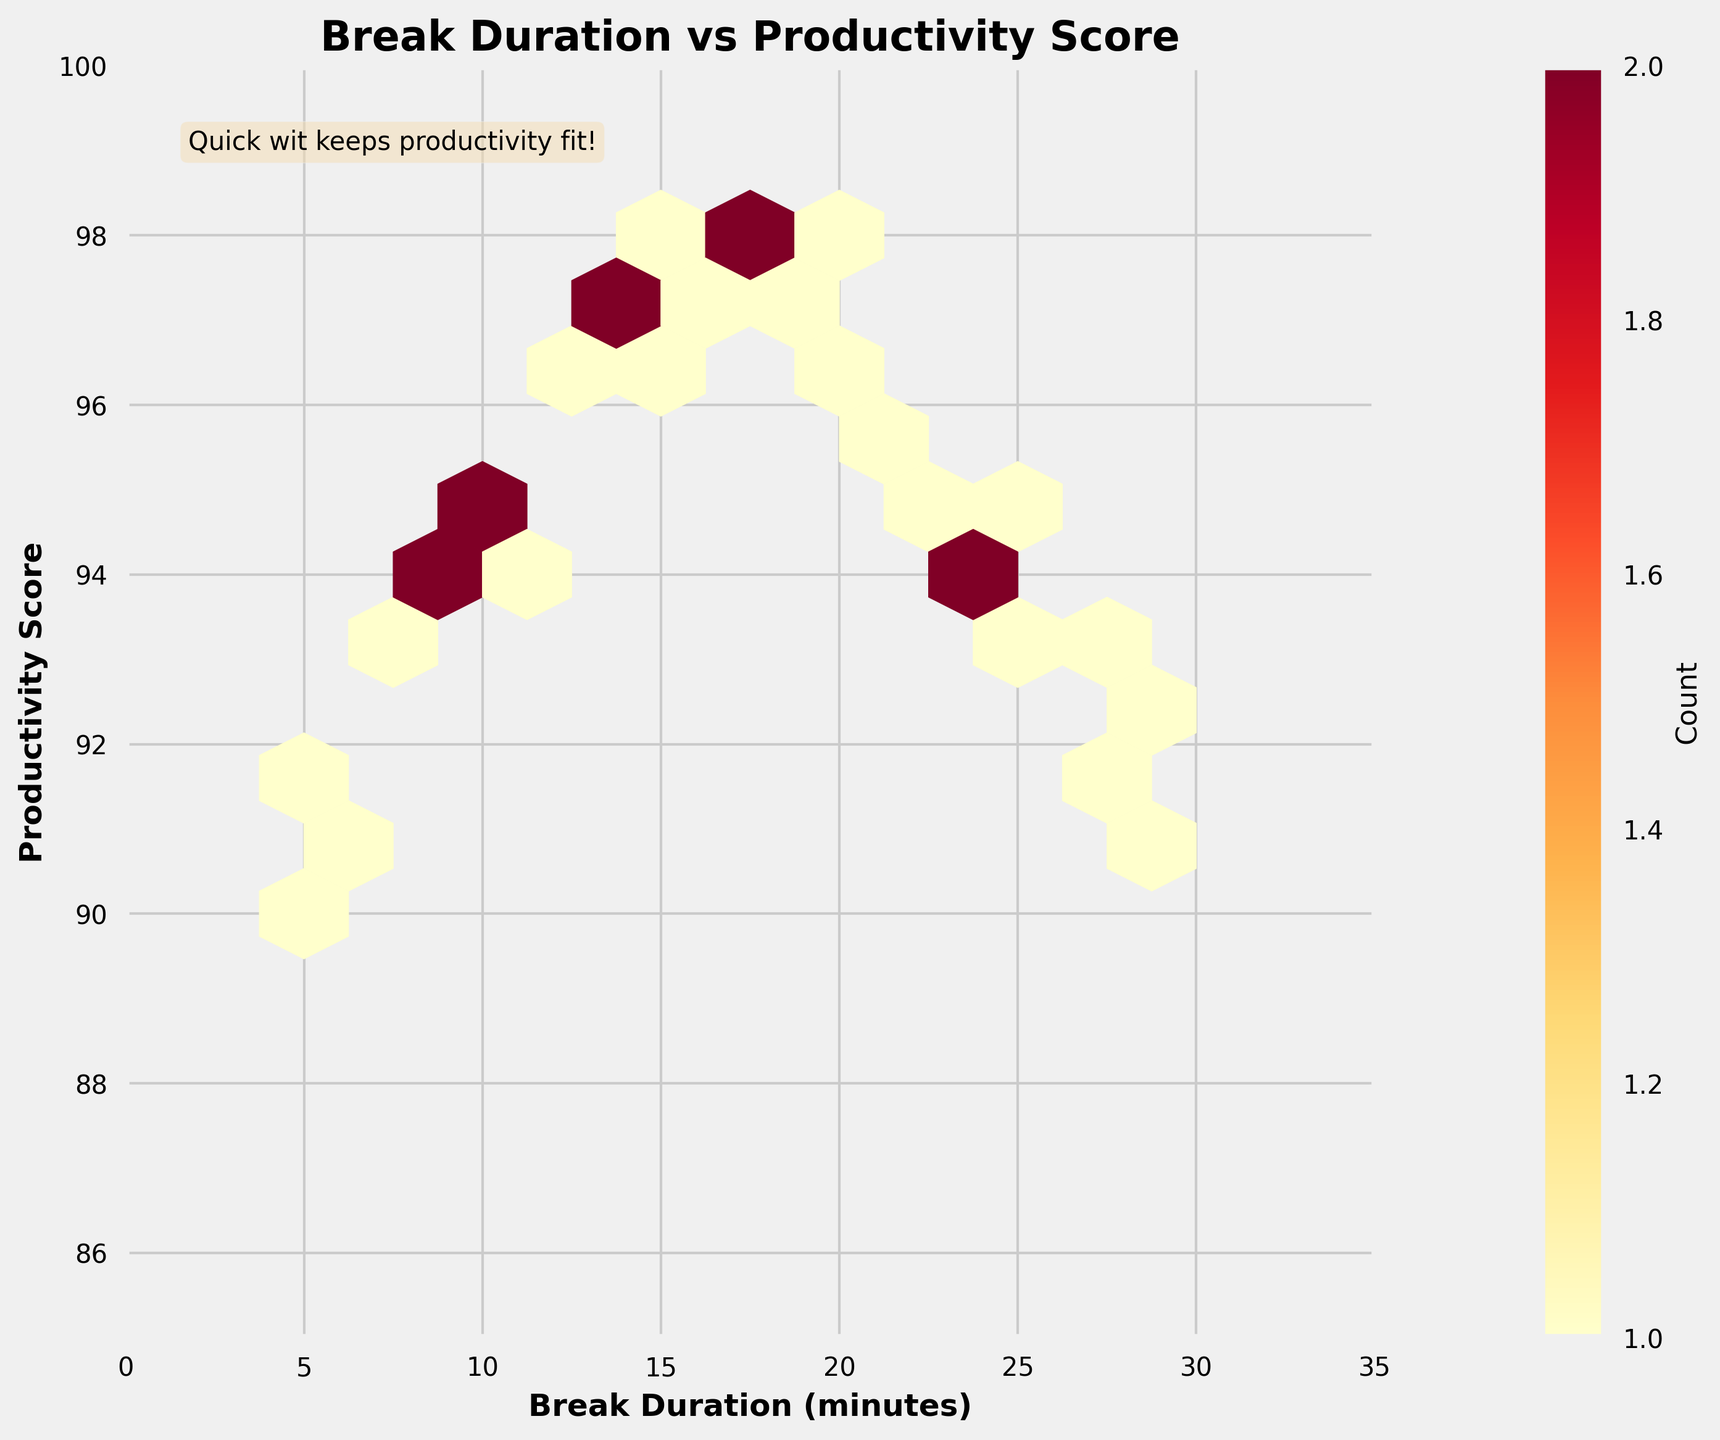What is the title of the figure? The title of the figure is located at the top and is formatted in bold. It directly states the primary focus of the figure.
Answer: Break Duration vs Productivity Score What are the labels for the x-axis and y-axis? The x-axis and y-axis labels are found along the horizontal and vertical axes, respectively. They describe the two variables being compared in the plot.
Answer: Break Duration (minutes) and Productivity Score What range do the Break Duration (minutes) values cover on the x-axis? The x-axis values range from 0 to 35, as indicated by the axis limits set in the figure.
Answer: 0 to 35 What is the color gradient used in the hexbin plot? The color gradient shown in the figure runs from lighter to darker shades of yellow, orange, and red, indicating different densities of data points.
Answer: Yellow to Red How many bins contain data points for break durations between 10 and 20 minutes? By visually inspecting the hexbin plot, count the number of hexagonal bins that fall within the x-axis range of 10 to 20 minutes.
Answer: Multiple Do longer break durations generally lead to higher productivity scores? By observing the overall distribution and color density in the plot, we can infer the relationship between break durations and productivity scores.
Answer: No clear trend Is there a clustering of break duration values that correspond to higher productivity scores? Look for areas in the plot where the hexagons are densely populated and correlate with higher productivity scores (typically darker shades).
Answer: Yes What is the approximate productivity score for a break duration of 15 minutes? Locate the hexagons at approximately 15 minutes on the x-axis and observe the corresponding y-axis productivity score values.
Answer: Around 97 Which break duration has the lowest recorded productivity score? Identify the lowest y-axis value and match it with its corresponding break duration on the x-axis.
Answer: 5 minutes Where are the "Quick wit keeps productivity fit!" text located within the figure? The phrase is positioned on the top-left corner within the plot area and is surrounded by a slightly transparent box.
Answer: Top-left corner 